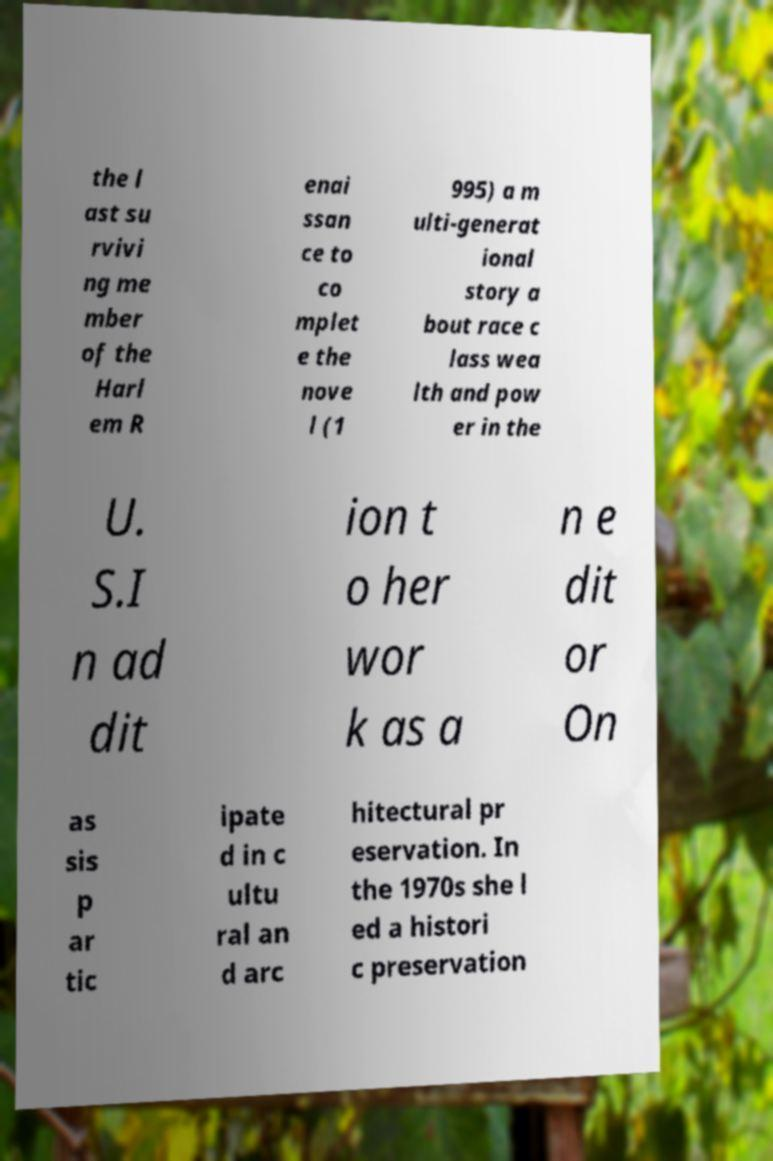Could you assist in decoding the text presented in this image and type it out clearly? the l ast su rvivi ng me mber of the Harl em R enai ssan ce to co mplet e the nove l (1 995) a m ulti-generat ional story a bout race c lass wea lth and pow er in the U. S.I n ad dit ion t o her wor k as a n e dit or On as sis p ar tic ipate d in c ultu ral an d arc hitectural pr eservation. In the 1970s she l ed a histori c preservation 